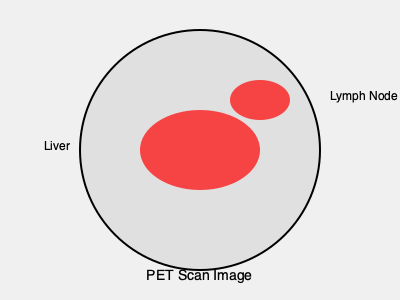Based on the PET scan image provided, which cancer stage would you assign to this patient, considering the primary tumor in the liver and the suspicious lymph node involvement? To determine the cancer stage based on this PET scan image, we need to follow these steps:

1. Identify the primary tumor:
   The large red area in the center of the image represents an FDG-avid (metabolically active) mass in the liver, indicating the primary tumor.

2. Assess lymph node involvement:
   The smaller red area in the upper right quadrant represents an FDG-avid lymph node, suggesting metastatic involvement.

3. Look for distant metastases:
   There are no other visible FDG-avid areas in this image, suggesting no distant metastases are present.

4. Apply TNM staging:
   - T (Primary Tumor): The tumor is confined to the liver, but size cannot be determined from this image alone.
   - N (Regional Lymph Nodes): There is evidence of regional lymph node involvement (N1).
   - M (Distant Metastasis): No evidence of distant metastasis (M0).

5. Determine the stage:
   For most cancers originating in the liver (e.g., hepatocellular carcinoma):
   - The presence of regional lymph node metastasis (N1) automatically classifies the cancer as stage IVA, regardless of the tumor size.
   - Stage IVA is typically defined as any T, N1, M0.

Therefore, based on the information provided in this PET scan image, the cancer would be classified as Stage IVA.
Answer: Stage IVA 